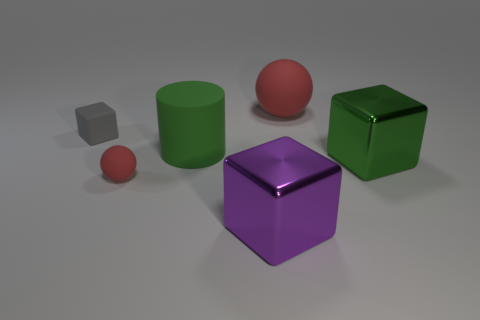How many other objects are there of the same size as the rubber cube?
Keep it short and to the point. 1. What shape is the thing that is both in front of the large green cube and on the right side of the large green rubber cylinder?
Your answer should be compact. Cube. Is the size of the rubber cylinder the same as the rubber block?
Provide a short and direct response. No. Are there any large blue objects made of the same material as the purple cube?
Your answer should be compact. No. What size is the cube that is the same color as the large rubber cylinder?
Provide a succinct answer. Large. What number of cubes are both behind the tiny ball and in front of the green rubber cylinder?
Give a very brief answer. 1. There is a purple block in front of the large red thing; what is it made of?
Your answer should be very brief. Metal. How many big spheres have the same color as the tiny matte sphere?
Your response must be concise. 1. There is a green cylinder that is made of the same material as the gray cube; what size is it?
Your response must be concise. Large. How many objects are gray things or tiny matte objects?
Provide a succinct answer. 2. 